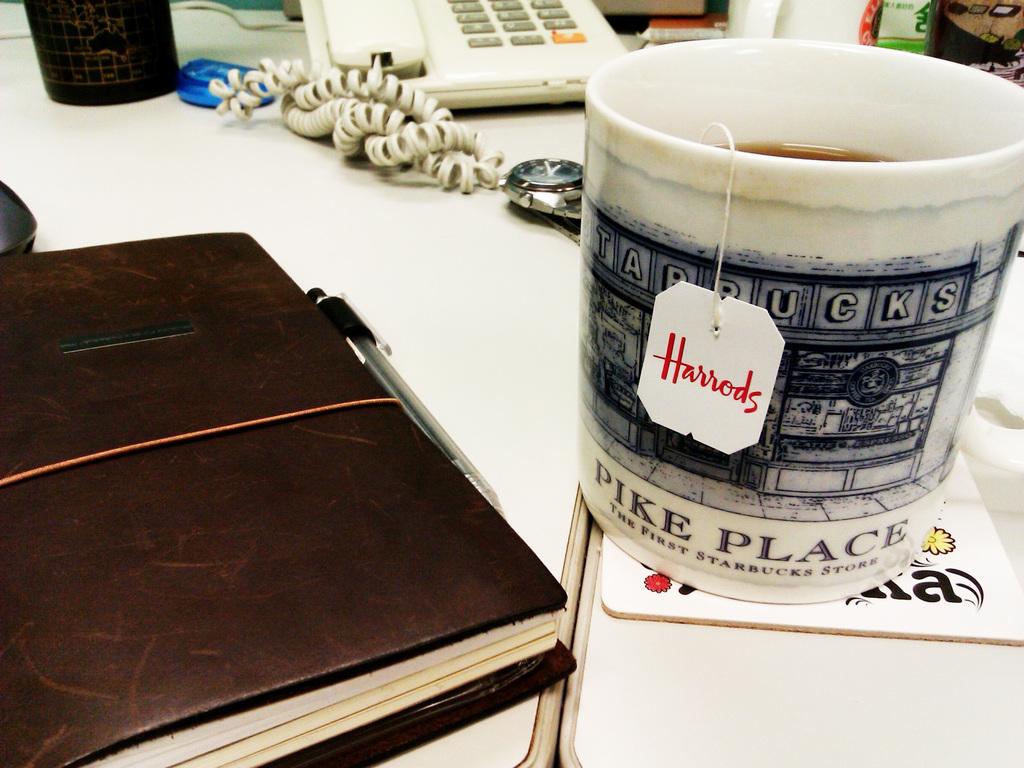What is the name on the teabag?
Give a very brief answer. Harrods. Where was the first starbucks store?
Provide a succinct answer. Pike place. 